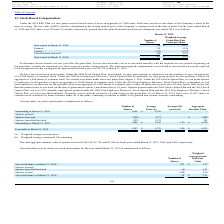From Avx Corporation's financial document, What is the total aggregate intrinsic value of options exercised for the fiscal years ended March 31, 2017 to 2019 respectively? The document contains multiple relevant values: $2,149, $1,724, $1,944. From the document: "value of options exercised is $2,149, $1,724, and $1,944 for fiscal years ended March 31, 2017, 2018, and 2019, respectively. te intrinsic value of op..." Also, What is the number of share options granted between March 31, 2018 and 2019 respectively? The document shows two values: 0 and 326. From the document: "Options exercised (326) 13.11 - $ 1,944 Outstanding at March 31, 2018 1,894 $ 12.90 - -..." Also, What is the number of shares outstanding at March 31, 2018 and 2019 respectively? The document shows two values: 1,894 and 1,446. From the document: "Outstanding at March 31, 2019 1,446 $ 12.82 3.29 $ 6,528 Outstanding at March 31, 2018 1,894 $ 12.90 - -..." Also, can you calculate: What is the total aggregate intrinsic value of options exercised between 2017 to 2019? Based on the calculation: 2,149 + 1,724 + 1,944 , the result is 5817. This is based on the information: "Options exercised (326) 13.11 - $ 1,944 intrinsic value of options exercised is $2,149, $1,724, and $1,944 for fiscal years ended March 31, 2017, 2018, and 2019, respectively. ggregate intrinsic value..." The key data points involved are: 1,724, 1,944, 2,149. Also, can you calculate: What is the percentage of total aggregate intrinsic value of options exercised as a percentage of the aggregate intrinsic value exercisable at March 31, 2019? Based on the calculation: 1,944/6,253 , the result is 31.09 (percentage). This is based on the information: "xercisable at March 31, 2019 1,347 $ 12.70 3.08 $ 6,253 Options exercised (326) 13.11 - $ 1,944..." The key data points involved are: 1,944, 6,253. Also, can you calculate: What is the percentage change in the average price between March 31, 2018 and 2019? To answer this question, I need to perform calculations using the financial data. The calculation is: (12.70 - 12.90)/12.90 , which equals -1.55 (percentage). This is based on the information: "Outstanding at March 31, 2018 1,894 $ 12.90 - - Exercisable at March 31, 2019 1,347 $ 12.70 3.08 $ 6,253..." The key data points involved are: 12.70, 12.90. 